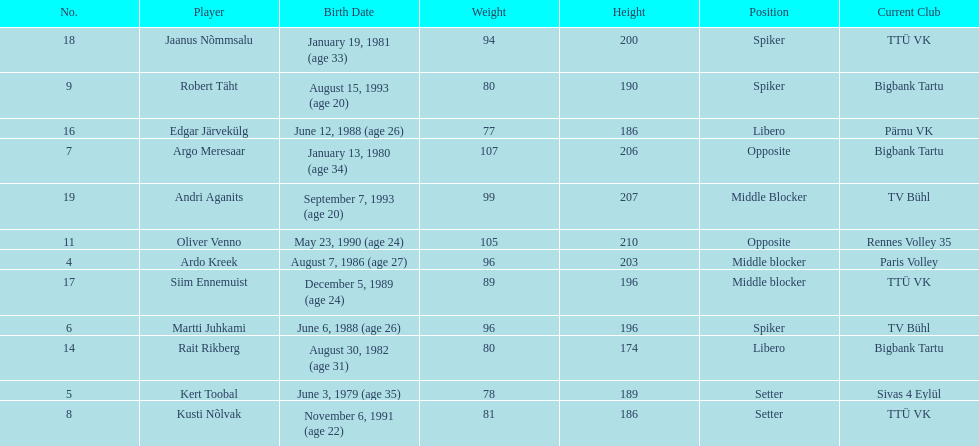What are the total number of players from france? 2. 